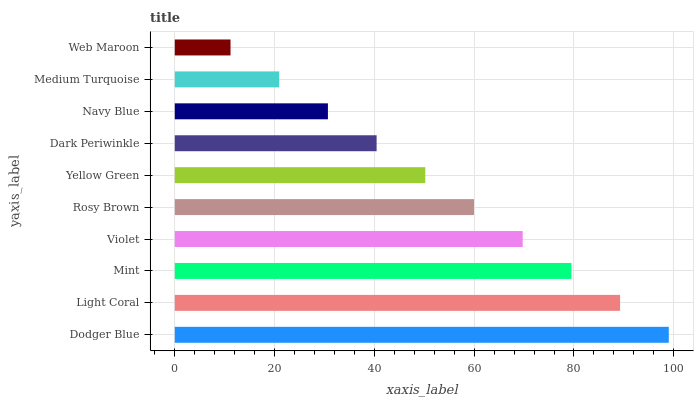Is Web Maroon the minimum?
Answer yes or no. Yes. Is Dodger Blue the maximum?
Answer yes or no. Yes. Is Light Coral the minimum?
Answer yes or no. No. Is Light Coral the maximum?
Answer yes or no. No. Is Dodger Blue greater than Light Coral?
Answer yes or no. Yes. Is Light Coral less than Dodger Blue?
Answer yes or no. Yes. Is Light Coral greater than Dodger Blue?
Answer yes or no. No. Is Dodger Blue less than Light Coral?
Answer yes or no. No. Is Rosy Brown the high median?
Answer yes or no. Yes. Is Yellow Green the low median?
Answer yes or no. Yes. Is Medium Turquoise the high median?
Answer yes or no. No. Is Mint the low median?
Answer yes or no. No. 